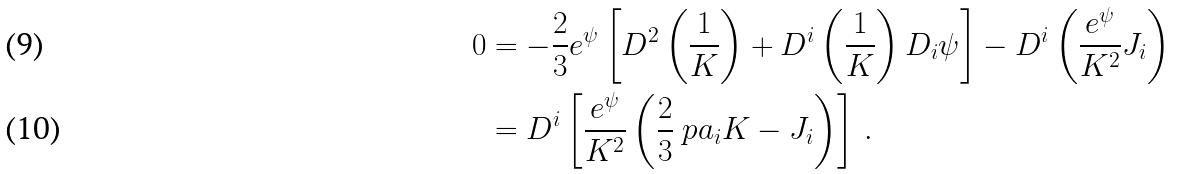Convert formula to latex. <formula><loc_0><loc_0><loc_500><loc_500>0 & = - \frac { 2 } { 3 } e ^ { \psi } \left [ D ^ { 2 } \left ( \frac { 1 } { K } \right ) + D ^ { i } \left ( \frac { 1 } { K } \right ) D _ { i } \psi \right ] - D ^ { i } \left ( \frac { e ^ { \psi } } { K ^ { 2 } } J _ { i } \right ) \\ & = D ^ { i } \left [ \frac { e ^ { \psi } } { K ^ { 2 } } \left ( \frac { 2 } { 3 } \ p a _ { i } K - J _ { i } \right ) \right ] \, .</formula> 